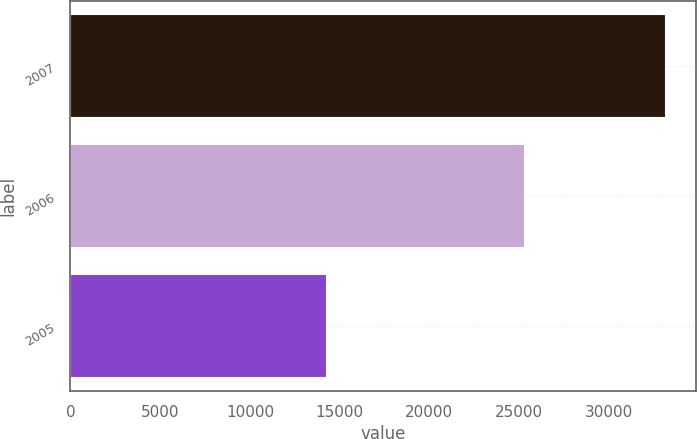Convert chart. <chart><loc_0><loc_0><loc_500><loc_500><bar_chart><fcel>2007<fcel>2006<fcel>2005<nl><fcel>33192<fcel>25305<fcel>14322<nl></chart> 